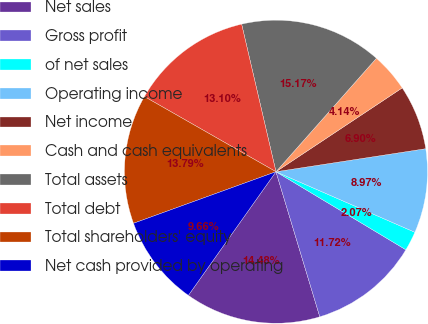<chart> <loc_0><loc_0><loc_500><loc_500><pie_chart><fcel>Net sales<fcel>Gross profit<fcel>of net sales<fcel>Operating income<fcel>Net income<fcel>Cash and cash equivalents<fcel>Total assets<fcel>Total debt<fcel>Total shareholders' equity<fcel>Net cash provided by operating<nl><fcel>14.48%<fcel>11.72%<fcel>2.07%<fcel>8.97%<fcel>6.9%<fcel>4.14%<fcel>15.17%<fcel>13.1%<fcel>13.79%<fcel>9.66%<nl></chart> 